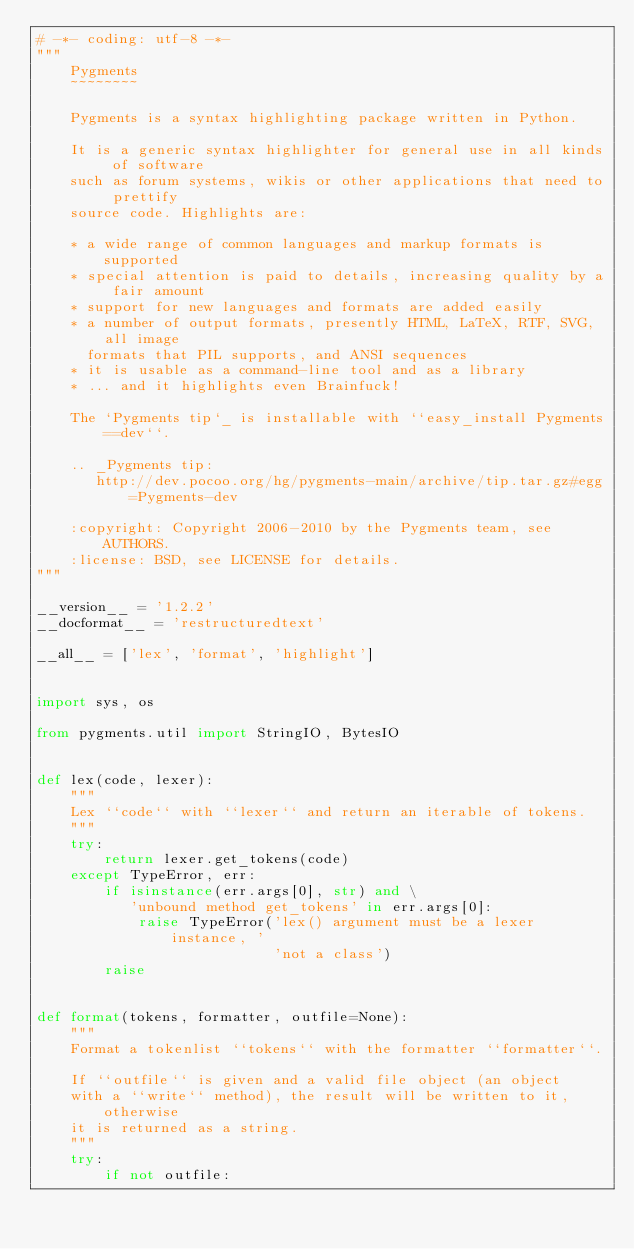Convert code to text. <code><loc_0><loc_0><loc_500><loc_500><_Python_># -*- coding: utf-8 -*-
"""
    Pygments
    ~~~~~~~~

    Pygments is a syntax highlighting package written in Python.

    It is a generic syntax highlighter for general use in all kinds of software
    such as forum systems, wikis or other applications that need to prettify
    source code. Highlights are:

    * a wide range of common languages and markup formats is supported
    * special attention is paid to details, increasing quality by a fair amount
    * support for new languages and formats are added easily
    * a number of output formats, presently HTML, LaTeX, RTF, SVG, all image
      formats that PIL supports, and ANSI sequences
    * it is usable as a command-line tool and as a library
    * ... and it highlights even Brainfuck!

    The `Pygments tip`_ is installable with ``easy_install Pygments==dev``.

    .. _Pygments tip:
       http://dev.pocoo.org/hg/pygments-main/archive/tip.tar.gz#egg=Pygments-dev

    :copyright: Copyright 2006-2010 by the Pygments team, see AUTHORS.
    :license: BSD, see LICENSE for details.
"""

__version__ = '1.2.2'
__docformat__ = 'restructuredtext'

__all__ = ['lex', 'format', 'highlight']


import sys, os

from pygments.util import StringIO, BytesIO


def lex(code, lexer):
    """
    Lex ``code`` with ``lexer`` and return an iterable of tokens.
    """
    try:
        return lexer.get_tokens(code)
    except TypeError, err:
        if isinstance(err.args[0], str) and \
           'unbound method get_tokens' in err.args[0]:
            raise TypeError('lex() argument must be a lexer instance, '
                            'not a class')
        raise


def format(tokens, formatter, outfile=None):
    """
    Format a tokenlist ``tokens`` with the formatter ``formatter``.

    If ``outfile`` is given and a valid file object (an object
    with a ``write`` method), the result will be written to it, otherwise
    it is returned as a string.
    """
    try:
        if not outfile:</code> 